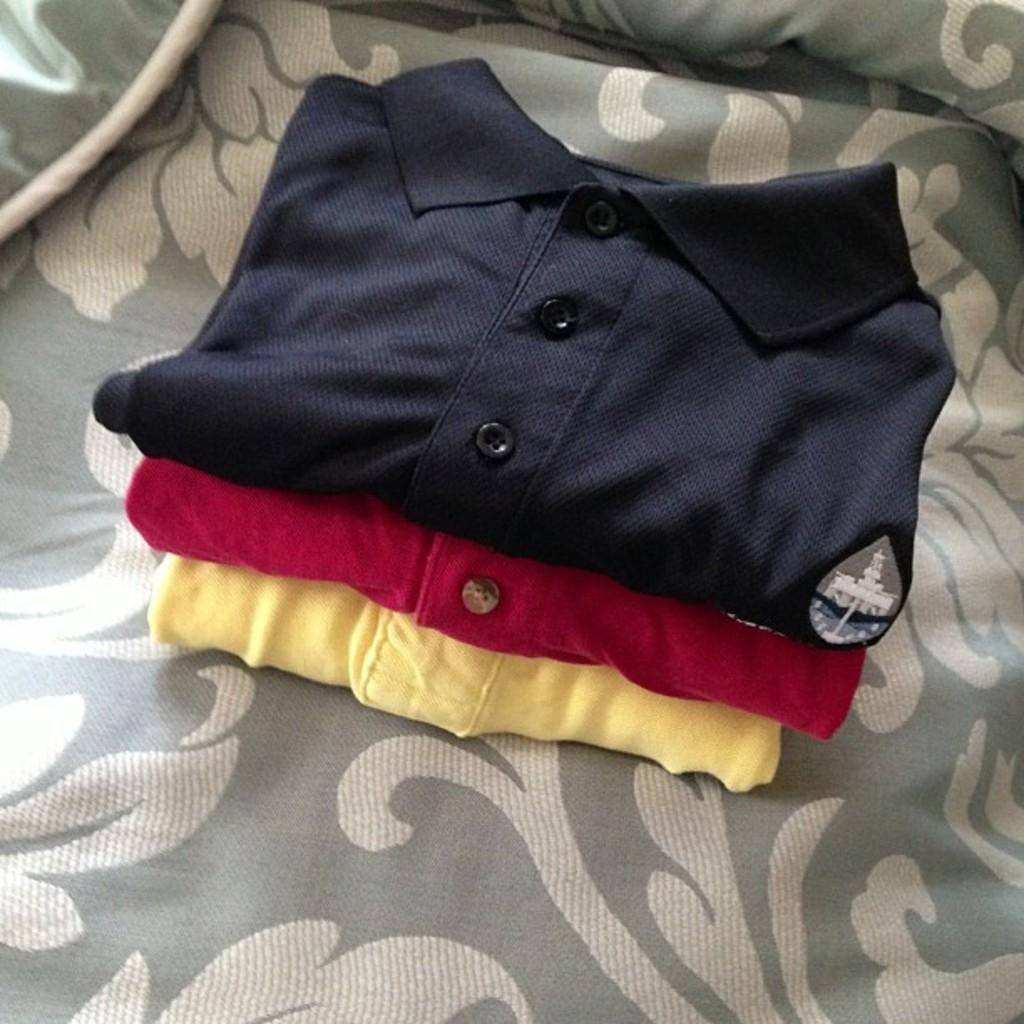What type of clothing is present in the image? There are polo t-shirts in the image. Can you describe the background of the image? There is cloth visible in the background of the image. What type of window can be seen in the image? There is no window present in the image; it only features polo t-shirts and cloth in the background. 